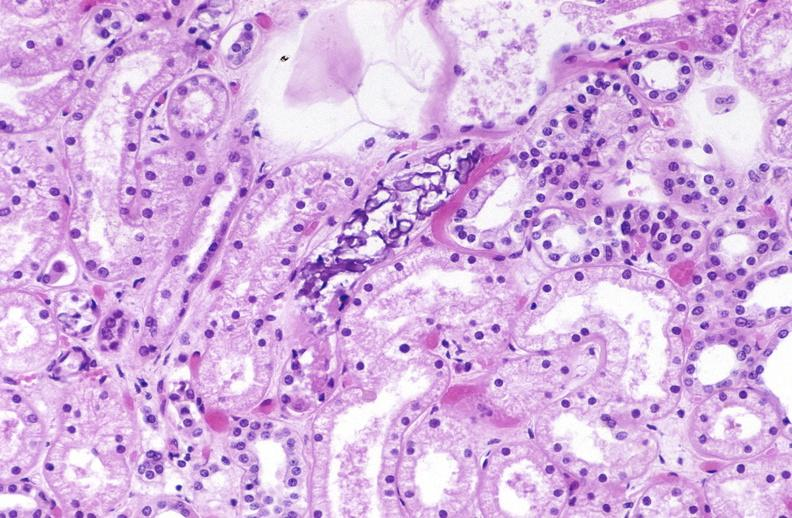s urinary present?
Answer the question using a single word or phrase. Yes 